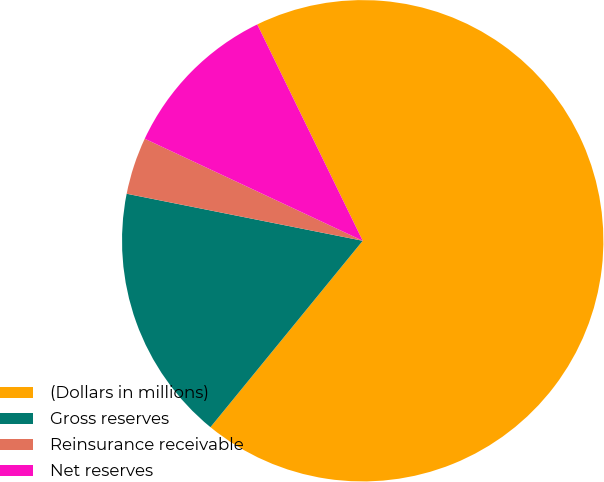Convert chart to OTSL. <chart><loc_0><loc_0><loc_500><loc_500><pie_chart><fcel>(Dollars in millions)<fcel>Gross reserves<fcel>Reinsurance receivable<fcel>Net reserves<nl><fcel>68.12%<fcel>17.23%<fcel>3.84%<fcel>10.81%<nl></chart> 